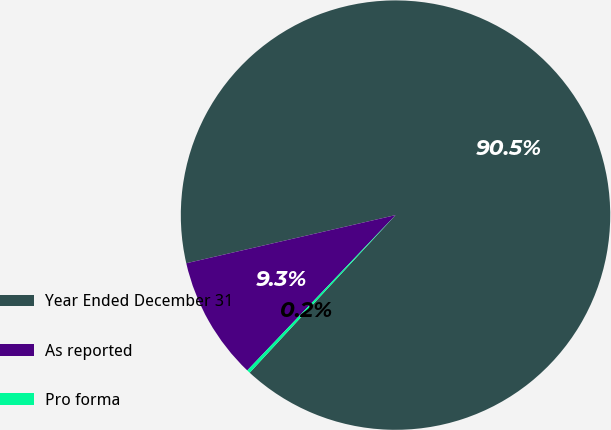Convert chart. <chart><loc_0><loc_0><loc_500><loc_500><pie_chart><fcel>Year Ended December 31<fcel>As reported<fcel>Pro forma<nl><fcel>90.48%<fcel>9.27%<fcel>0.25%<nl></chart> 